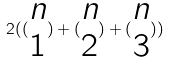<formula> <loc_0><loc_0><loc_500><loc_500>2 ( ( \begin{matrix} n \\ 1 \end{matrix} ) + ( \begin{matrix} n \\ 2 \end{matrix} ) + ( \begin{matrix} n \\ 3 \end{matrix} ) )</formula> 